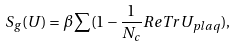<formula> <loc_0><loc_0><loc_500><loc_500>S _ { g } ( U ) = \beta \sum ( 1 - \frac { 1 } { N _ { c } } R e T r U _ { p l a q } ) ,</formula> 